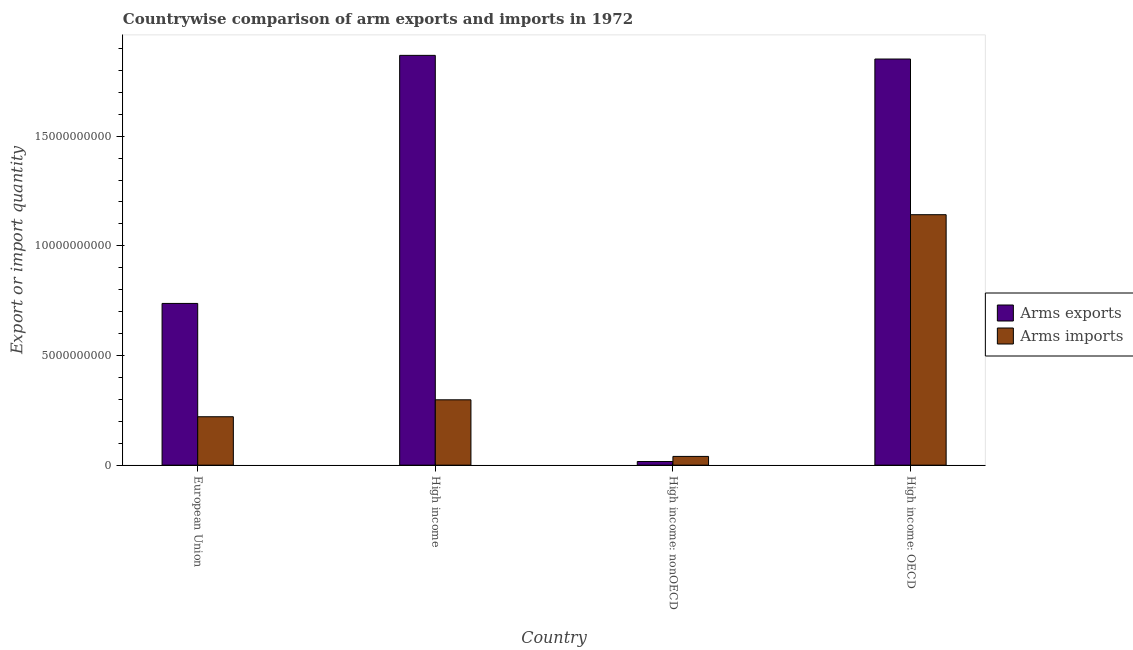How many different coloured bars are there?
Offer a terse response. 2. Are the number of bars per tick equal to the number of legend labels?
Your response must be concise. Yes. How many bars are there on the 4th tick from the right?
Make the answer very short. 2. What is the label of the 2nd group of bars from the left?
Offer a very short reply. High income. What is the arms exports in European Union?
Provide a succinct answer. 7.37e+09. Across all countries, what is the maximum arms exports?
Give a very brief answer. 1.87e+1. Across all countries, what is the minimum arms imports?
Your response must be concise. 3.99e+08. In which country was the arms exports minimum?
Offer a very short reply. High income: nonOECD. What is the total arms imports in the graph?
Ensure brevity in your answer.  1.70e+1. What is the difference between the arms exports in European Union and that in High income?
Provide a short and direct response. -1.13e+1. What is the difference between the arms imports in European Union and the arms exports in High income: nonOECD?
Make the answer very short. 2.04e+09. What is the average arms exports per country?
Your answer should be very brief. 1.12e+1. What is the difference between the arms exports and arms imports in High income?
Give a very brief answer. 1.57e+1. In how many countries, is the arms imports greater than 13000000000 ?
Your answer should be compact. 0. What is the ratio of the arms exports in European Union to that in High income: nonOECD?
Your answer should be very brief. 44.16. Is the arms exports in High income: OECD less than that in High income: nonOECD?
Make the answer very short. No. What is the difference between the highest and the second highest arms imports?
Ensure brevity in your answer.  8.44e+09. What is the difference between the highest and the lowest arms imports?
Ensure brevity in your answer.  1.10e+1. In how many countries, is the arms exports greater than the average arms exports taken over all countries?
Offer a very short reply. 2. Is the sum of the arms exports in European Union and High income greater than the maximum arms imports across all countries?
Your answer should be compact. Yes. What does the 1st bar from the left in High income: nonOECD represents?
Keep it short and to the point. Arms exports. What does the 1st bar from the right in European Union represents?
Your response must be concise. Arms imports. How many bars are there?
Offer a terse response. 8. Are all the bars in the graph horizontal?
Provide a succinct answer. No. What is the difference between two consecutive major ticks on the Y-axis?
Your answer should be very brief. 5.00e+09. Does the graph contain any zero values?
Your answer should be very brief. No. Does the graph contain grids?
Your response must be concise. No. Where does the legend appear in the graph?
Your answer should be very brief. Center right. How are the legend labels stacked?
Give a very brief answer. Vertical. What is the title of the graph?
Offer a very short reply. Countrywise comparison of arm exports and imports in 1972. What is the label or title of the Y-axis?
Your answer should be very brief. Export or import quantity. What is the Export or import quantity of Arms exports in European Union?
Your answer should be compact. 7.37e+09. What is the Export or import quantity of Arms imports in European Union?
Your answer should be very brief. 2.21e+09. What is the Export or import quantity in Arms exports in High income?
Your response must be concise. 1.87e+1. What is the Export or import quantity of Arms imports in High income?
Your answer should be very brief. 2.98e+09. What is the Export or import quantity in Arms exports in High income: nonOECD?
Provide a short and direct response. 1.67e+08. What is the Export or import quantity of Arms imports in High income: nonOECD?
Provide a short and direct response. 3.99e+08. What is the Export or import quantity in Arms exports in High income: OECD?
Keep it short and to the point. 1.85e+1. What is the Export or import quantity in Arms imports in High income: OECD?
Give a very brief answer. 1.14e+1. Across all countries, what is the maximum Export or import quantity of Arms exports?
Your answer should be compact. 1.87e+1. Across all countries, what is the maximum Export or import quantity of Arms imports?
Offer a terse response. 1.14e+1. Across all countries, what is the minimum Export or import quantity of Arms exports?
Provide a short and direct response. 1.67e+08. Across all countries, what is the minimum Export or import quantity of Arms imports?
Offer a very short reply. 3.99e+08. What is the total Export or import quantity of Arms exports in the graph?
Your answer should be compact. 4.47e+1. What is the total Export or import quantity of Arms imports in the graph?
Your response must be concise. 1.70e+1. What is the difference between the Export or import quantity of Arms exports in European Union and that in High income?
Your response must be concise. -1.13e+1. What is the difference between the Export or import quantity of Arms imports in European Union and that in High income?
Keep it short and to the point. -7.72e+08. What is the difference between the Export or import quantity of Arms exports in European Union and that in High income: nonOECD?
Your answer should be compact. 7.21e+09. What is the difference between the Export or import quantity of Arms imports in European Union and that in High income: nonOECD?
Your response must be concise. 1.81e+09. What is the difference between the Export or import quantity in Arms exports in European Union and that in High income: OECD?
Your answer should be compact. -1.11e+1. What is the difference between the Export or import quantity of Arms imports in European Union and that in High income: OECD?
Make the answer very short. -9.21e+09. What is the difference between the Export or import quantity of Arms exports in High income and that in High income: nonOECD?
Ensure brevity in your answer.  1.85e+1. What is the difference between the Export or import quantity in Arms imports in High income and that in High income: nonOECD?
Provide a succinct answer. 2.58e+09. What is the difference between the Export or import quantity of Arms exports in High income and that in High income: OECD?
Give a very brief answer. 1.67e+08. What is the difference between the Export or import quantity in Arms imports in High income and that in High income: OECD?
Keep it short and to the point. -8.44e+09. What is the difference between the Export or import quantity of Arms exports in High income: nonOECD and that in High income: OECD?
Make the answer very short. -1.84e+1. What is the difference between the Export or import quantity in Arms imports in High income: nonOECD and that in High income: OECD?
Offer a terse response. -1.10e+1. What is the difference between the Export or import quantity in Arms exports in European Union and the Export or import quantity in Arms imports in High income?
Give a very brief answer. 4.39e+09. What is the difference between the Export or import quantity in Arms exports in European Union and the Export or import quantity in Arms imports in High income: nonOECD?
Ensure brevity in your answer.  6.98e+09. What is the difference between the Export or import quantity in Arms exports in European Union and the Export or import quantity in Arms imports in High income: OECD?
Provide a succinct answer. -4.05e+09. What is the difference between the Export or import quantity in Arms exports in High income and the Export or import quantity in Arms imports in High income: nonOECD?
Keep it short and to the point. 1.83e+1. What is the difference between the Export or import quantity in Arms exports in High income and the Export or import quantity in Arms imports in High income: OECD?
Keep it short and to the point. 7.26e+09. What is the difference between the Export or import quantity in Arms exports in High income: nonOECD and the Export or import quantity in Arms imports in High income: OECD?
Make the answer very short. -1.13e+1. What is the average Export or import quantity of Arms exports per country?
Offer a terse response. 1.12e+1. What is the average Export or import quantity of Arms imports per country?
Ensure brevity in your answer.  4.25e+09. What is the difference between the Export or import quantity of Arms exports and Export or import quantity of Arms imports in European Union?
Keep it short and to the point. 5.17e+09. What is the difference between the Export or import quantity in Arms exports and Export or import quantity in Arms imports in High income?
Provide a short and direct response. 1.57e+1. What is the difference between the Export or import quantity in Arms exports and Export or import quantity in Arms imports in High income: nonOECD?
Your response must be concise. -2.32e+08. What is the difference between the Export or import quantity of Arms exports and Export or import quantity of Arms imports in High income: OECD?
Offer a terse response. 7.10e+09. What is the ratio of the Export or import quantity of Arms exports in European Union to that in High income?
Your answer should be very brief. 0.39. What is the ratio of the Export or import quantity in Arms imports in European Union to that in High income?
Keep it short and to the point. 0.74. What is the ratio of the Export or import quantity in Arms exports in European Union to that in High income: nonOECD?
Keep it short and to the point. 44.16. What is the ratio of the Export or import quantity of Arms imports in European Union to that in High income: nonOECD?
Keep it short and to the point. 5.53. What is the ratio of the Export or import quantity of Arms exports in European Union to that in High income: OECD?
Offer a very short reply. 0.4. What is the ratio of the Export or import quantity of Arms imports in European Union to that in High income: OECD?
Keep it short and to the point. 0.19. What is the ratio of the Export or import quantity in Arms exports in High income to that in High income: nonOECD?
Your answer should be compact. 111.89. What is the ratio of the Export or import quantity in Arms imports in High income to that in High income: nonOECD?
Make the answer very short. 7.47. What is the ratio of the Export or import quantity of Arms exports in High income to that in High income: OECD?
Provide a short and direct response. 1.01. What is the ratio of the Export or import quantity in Arms imports in High income to that in High income: OECD?
Your answer should be compact. 0.26. What is the ratio of the Export or import quantity in Arms exports in High income: nonOECD to that in High income: OECD?
Provide a succinct answer. 0.01. What is the ratio of the Export or import quantity in Arms imports in High income: nonOECD to that in High income: OECD?
Make the answer very short. 0.03. What is the difference between the highest and the second highest Export or import quantity in Arms exports?
Provide a short and direct response. 1.67e+08. What is the difference between the highest and the second highest Export or import quantity of Arms imports?
Your answer should be compact. 8.44e+09. What is the difference between the highest and the lowest Export or import quantity of Arms exports?
Ensure brevity in your answer.  1.85e+1. What is the difference between the highest and the lowest Export or import quantity in Arms imports?
Offer a very short reply. 1.10e+1. 